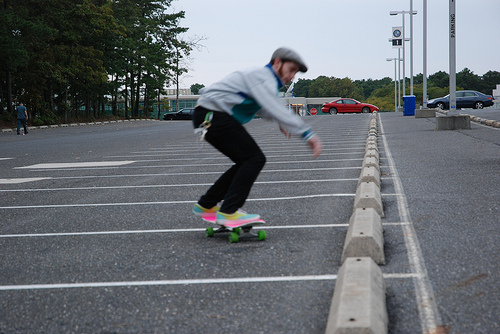What is the skateboarder wearing? The skateboarder is wearing a light-colored helmet for safety, a dark jacket, and light-colored pants which provide a comfortable attire for the activity. 